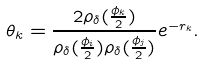Convert formula to latex. <formula><loc_0><loc_0><loc_500><loc_500>\theta _ { k } = \frac { 2 \rho _ { \delta } ( \frac { \phi _ { k } } 2 ) } { \rho _ { \delta } ( \frac { \phi _ { i } } 2 ) \rho _ { \delta } ( \frac { \phi _ { j } } 2 ) } e ^ { - r _ { k } } .</formula> 